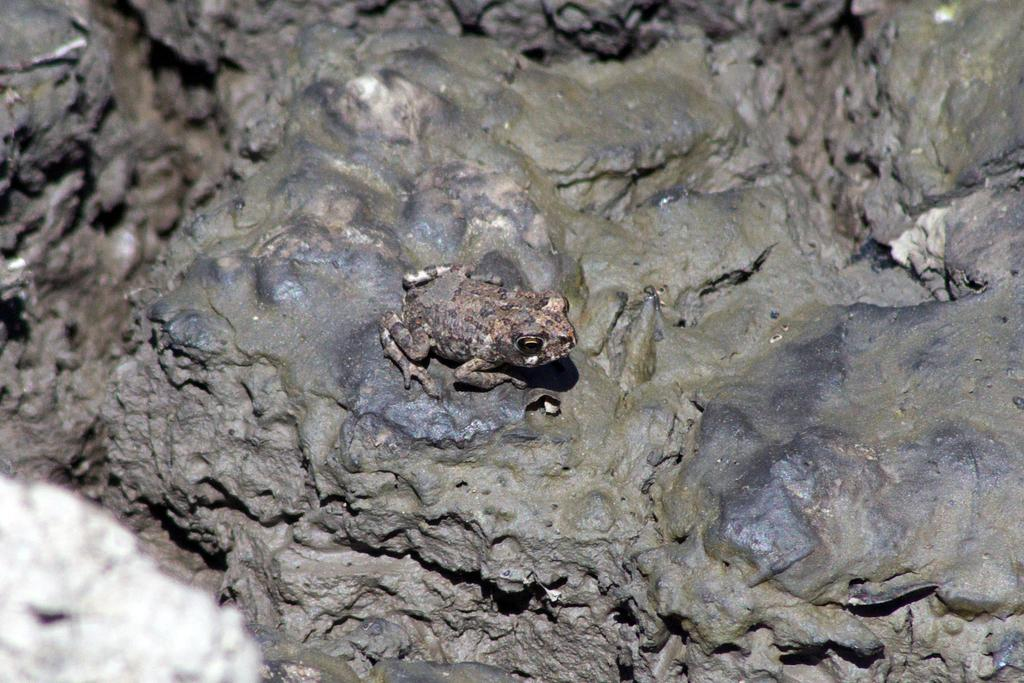What animal is present in the image? There is a frog in the image. Where is the frog located? The frog is on the mud. Can you describe the object in the left bottom corner of the image? Unfortunately, the provided facts do not give any information about the object in the left bottom corner. What is the frog's desire in the image? There is no information about the frog's desires in the image. Is there an umbrella present in the image? There is no mention of an umbrella in the provided facts. 